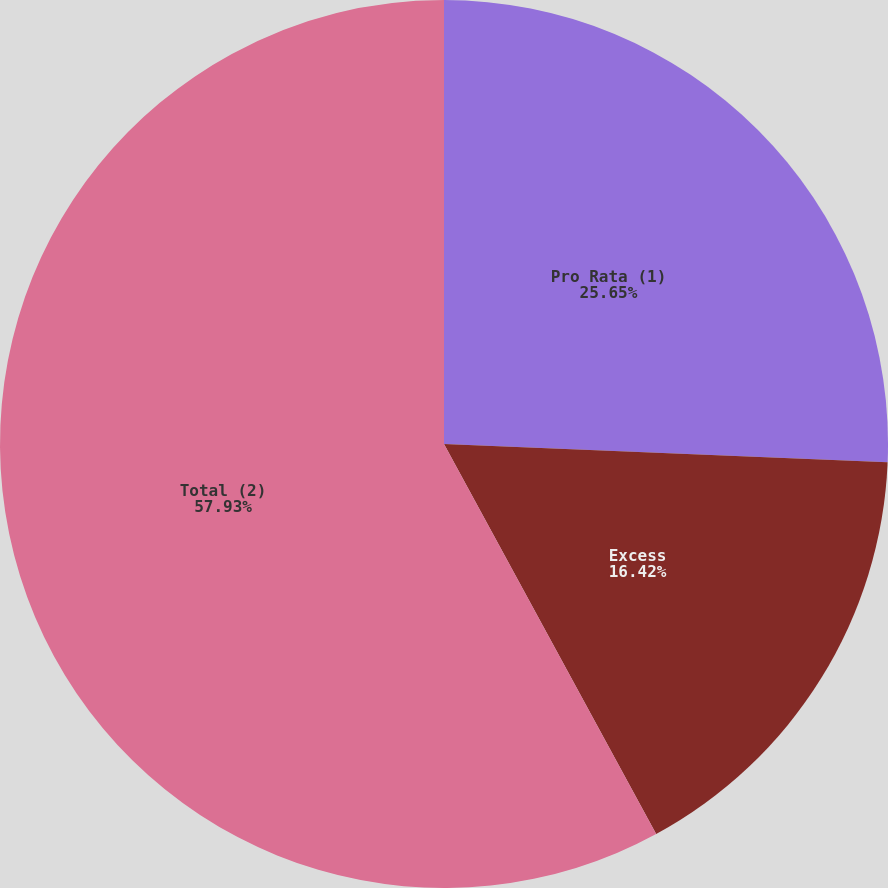Convert chart to OTSL. <chart><loc_0><loc_0><loc_500><loc_500><pie_chart><fcel>Pro Rata (1)<fcel>Excess<fcel>Total (2)<nl><fcel>25.65%<fcel>16.42%<fcel>57.93%<nl></chart> 